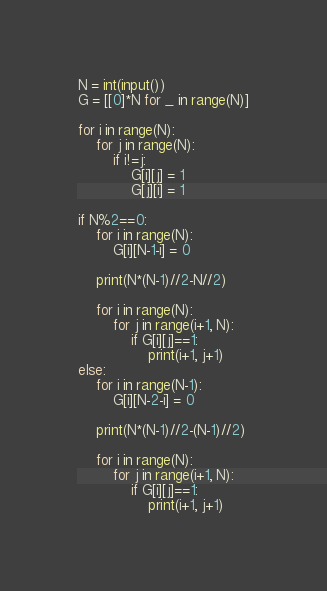<code> <loc_0><loc_0><loc_500><loc_500><_Python_>N = int(input())
G = [[0]*N for _ in range(N)]

for i in range(N):
    for j in range(N):
        if i!=j:
            G[i][j] = 1
            G[j][i] = 1

if N%2==0:
    for i in range(N):
        G[i][N-1-i] = 0
        
    print(N*(N-1)//2-N//2)
    
    for i in range(N):
        for j in range(i+1, N):
            if G[i][j]==1:
                print(i+1, j+1)
else:
    for i in range(N-1):
        G[i][N-2-i] = 0
        
    print(N*(N-1)//2-(N-1)//2)
    
    for i in range(N):
        for j in range(i+1, N):
            if G[i][j]==1:
                print(i+1, j+1)</code> 